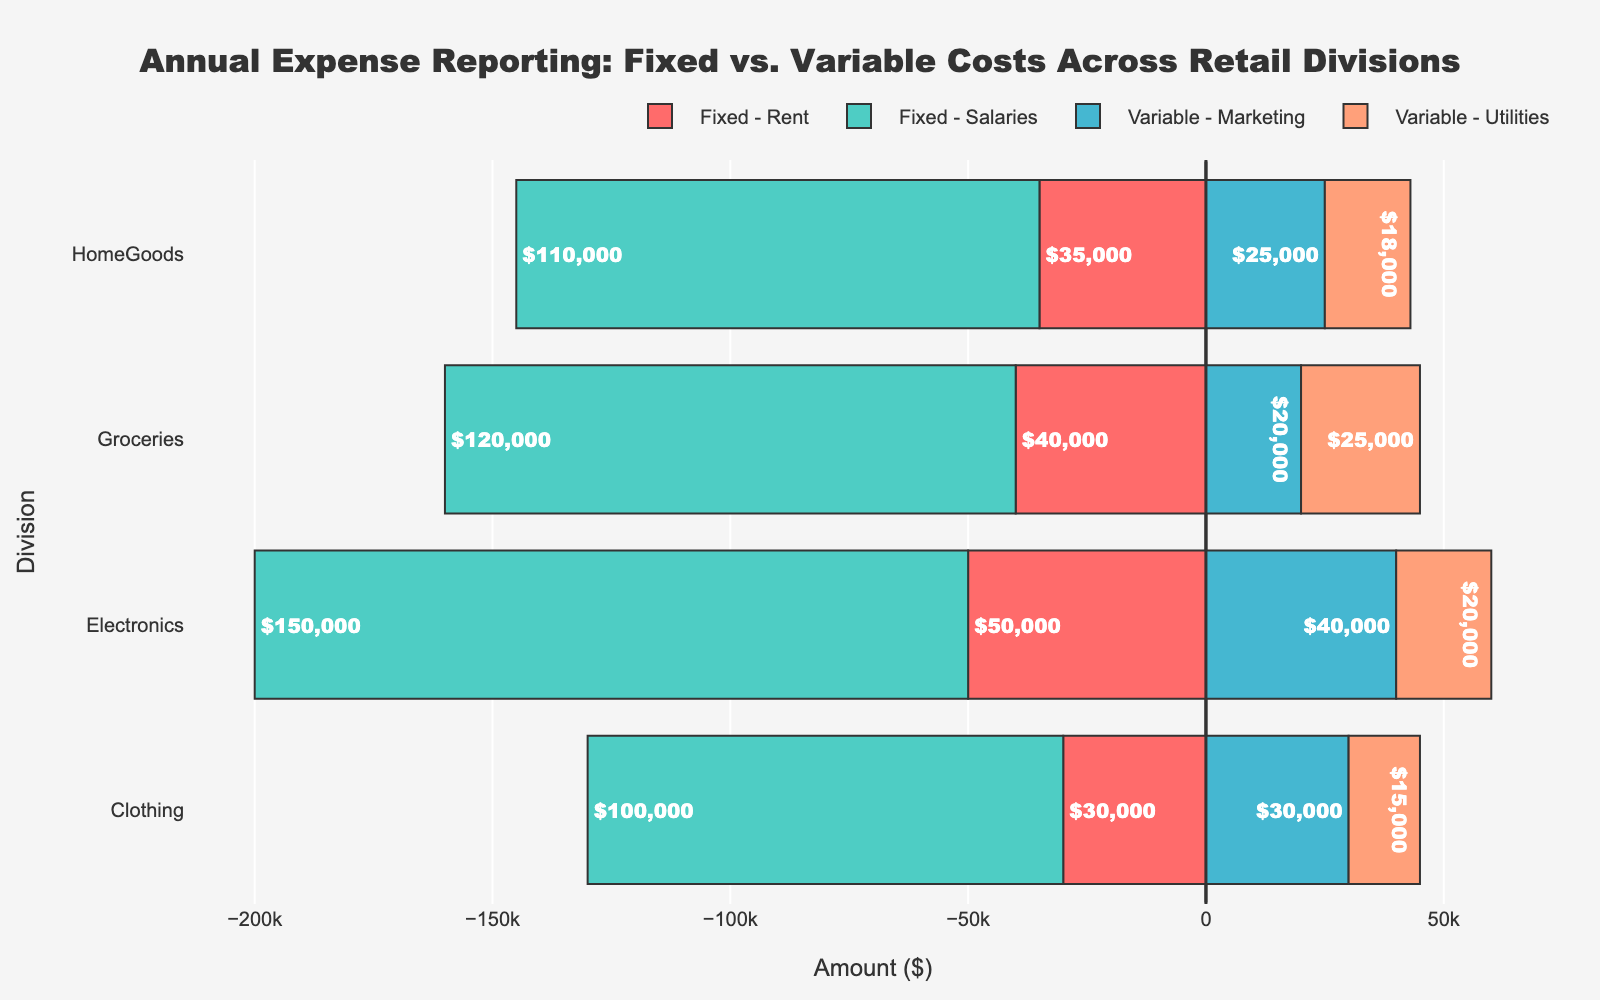Which division has the highest fixed costs? The fixed costs are represented by the lengths of the bars pointing to the left (negative values) for each division. Look for the longest bar segment among the fixed costs for each division.
Answer: Electronics What's the total variable cost for the HomeGoods division? Add the lengths of the bars pointing to the right (positive values) for Marketing and Utilities under the HomeGoods division.
Answer: $43,000 Compare the fixed costs of Rent for Electronics and Clothing. Which division has higher Rent expenses? Compare the lengths of the "Rent" bars under the fixed costs category for the Electronics and Clothing divisions.
Answer: Electronics Is the variable cost for Utilities greater in Groceries or Electronics? Compare the lengths of the Utilities bars under the variable costs category for the Groceries and Electronics divisions.
Answer: Groceries Which cost category has the smallest expense in the Clothing division? Look for the shortest bar segment under the Clothing division, accounting for both fixed and variable costs categories.
Answer: Utilities By how much does the combined fixed cost of Rent and Salaries in Groceries exceed that in HomeGoods? Calculate the total lengths of the Rent and Salaries bars under the fixed costs category for both Groceries and HomeGoods, then find the difference.
Answer: $15,000 What are the total fixed costs for the Electronics division? Add the lengths of the Rent and Salaries bars under the fixed costs category for the Electronics division.
Answer: $200,000 How do the total variable costs for the Clothing division compare to those of the HomeGoods division? Add the lengths of the bars pointing to the right (positive values) for Marketing and Utilities under each division, then compare the totals for Clothing and HomeGoods.
Answer: Clothing <$43,000, thus smaller Which cost category in the Groceries division has the highest expense? Identify the longest bar segment under the Groceries division, accounting for both fixed and variable costs categories.
Answer: Salaries 